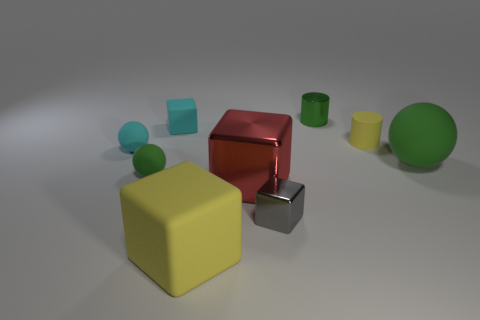Are there any green balls that have the same size as the gray block?
Provide a short and direct response. Yes. What is the material of the gray object that is the same size as the green metal object?
Your answer should be very brief. Metal. There is a yellow object in front of the cyan matte ball; what size is it?
Provide a succinct answer. Large. What is the size of the cyan cube?
Keep it short and to the point. Small. Does the yellow block have the same size as the green rubber object right of the small green metal object?
Your response must be concise. Yes. What is the color of the rubber block on the right side of the block behind the red shiny object?
Offer a very short reply. Yellow. Are there the same number of big green things that are to the left of the gray metal object and cyan spheres on the right side of the big green sphere?
Provide a short and direct response. Yes. Are the small sphere that is in front of the small cyan matte ball and the large red object made of the same material?
Provide a succinct answer. No. The tiny object that is right of the large red thing and in front of the small yellow cylinder is what color?
Offer a terse response. Gray. There is a tiny cylinder in front of the cyan cube; how many tiny green balls are right of it?
Your answer should be compact. 0. 